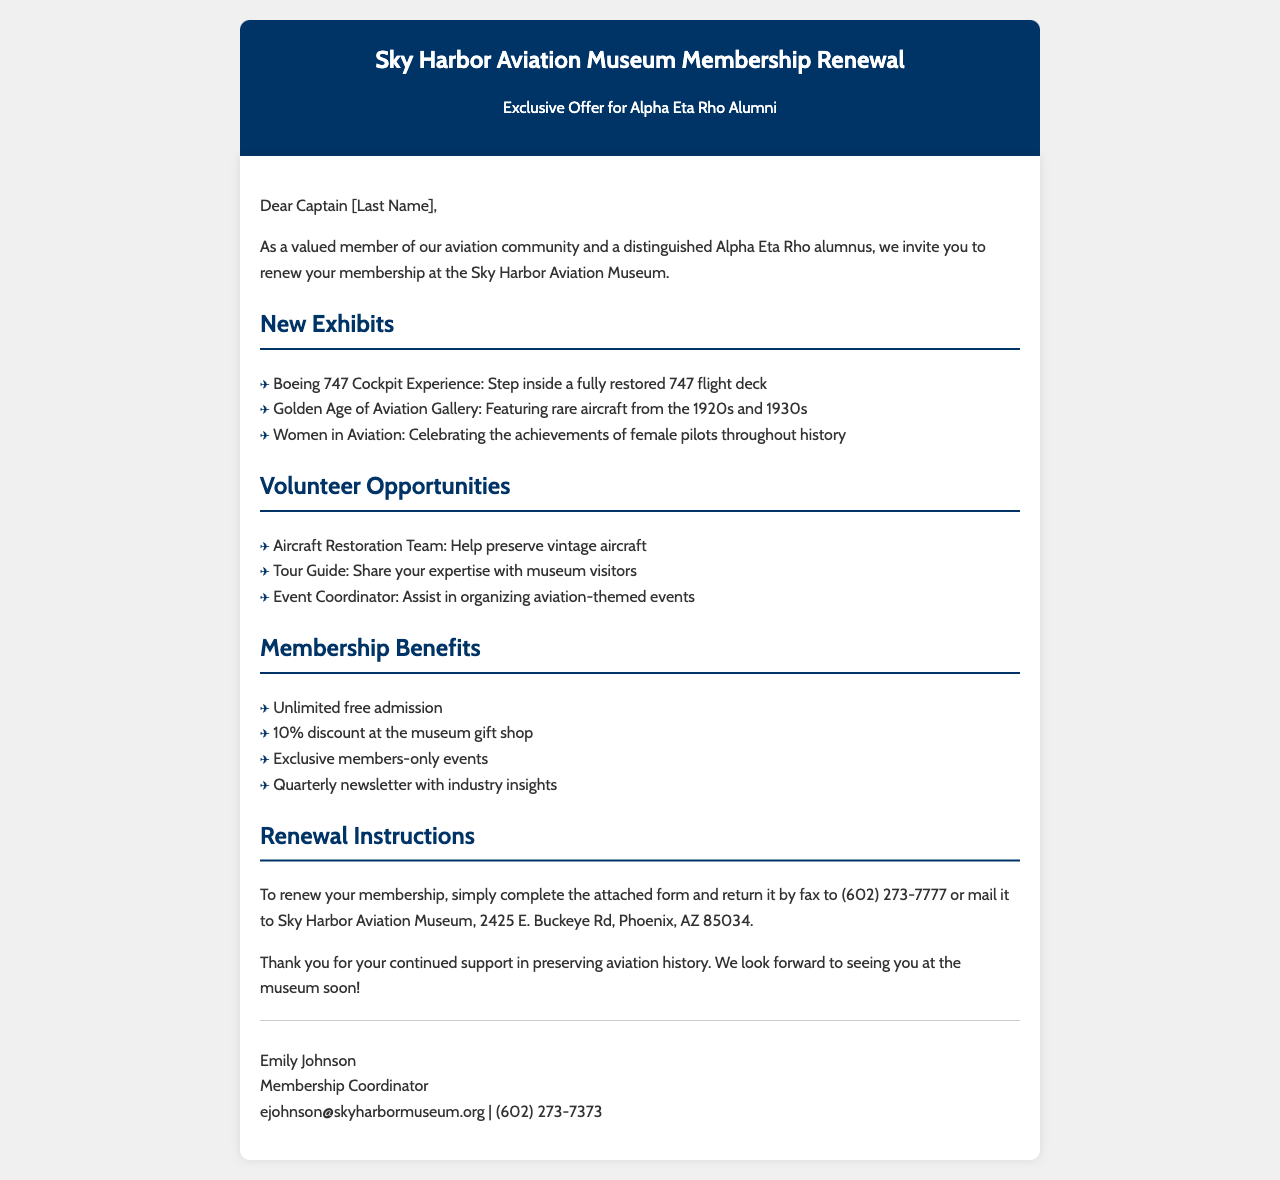what is the title of the document? The document is titled "Sky Harbor Aviation Museum Membership Renewal."
Answer: Sky Harbor Aviation Museum Membership Renewal who is the membership coordinator? The document provides the name of the coordinator at the end where it's signed.
Answer: Emily Johnson what is the fax number for returning the membership form? The fax number is mentioned in the instructions for renewing the membership.
Answer: (602) 273-7777 how many new exhibits are listed in the document? The document lists three new exhibits under the New Exhibits section.
Answer: 3 what volunteer opportunity involves helping to preserve aircraft? The document specifies a role that deals with aircraft restoration in the Volunteer Opportunities section.
Answer: Aircraft Restoration Team what discount do members receive at the museum gift shop? The Membership Benefits section outlines what discount members have in the gift shop.
Answer: 10% what is the main theme of the "Women in Aviation" exhibit? The document describes the focus of this exhibit, which highlights contributions in aviation.
Answer: Achievements of female pilots where is the Sky Harbor Aviation Museum located? The location of the museum is specified in the renewal instructions.
Answer: 2425 E. Buckeye Rd, Phoenix, AZ 85034 what should you do to renew your membership? The document provides instructions on how to renew membership by mentioning a specific action.
Answer: Complete the attached form and return it 